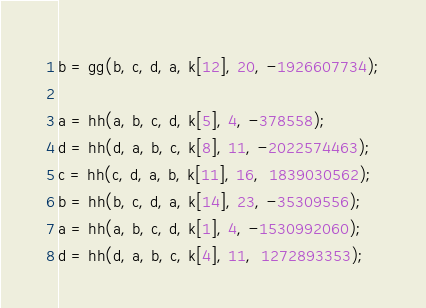<code> <loc_0><loc_0><loc_500><loc_500><_JavaScript_>b = gg(b, c, d, a, k[12], 20, -1926607734);

a = hh(a, b, c, d, k[5], 4, -378558);
d = hh(d, a, b, c, k[8], 11, -2022574463);
c = hh(c, d, a, b, k[11], 16,  1839030562);
b = hh(b, c, d, a, k[14], 23, -35309556);
a = hh(a, b, c, d, k[1], 4, -1530992060);
d = hh(d, a, b, c, k[4], 11,  1272893353);</code> 